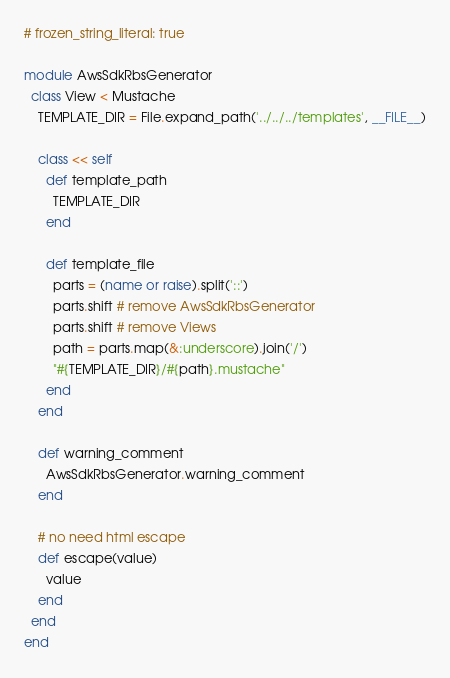<code> <loc_0><loc_0><loc_500><loc_500><_Ruby_># frozen_string_literal: true

module AwsSdkRbsGenerator
  class View < Mustache
    TEMPLATE_DIR = File.expand_path('../../../templates', __FILE__)

    class << self
      def template_path
        TEMPLATE_DIR
      end

      def template_file
        parts = (name or raise).split('::')
        parts.shift # remove AwsSdkRbsGenerator
        parts.shift # remove Views
        path = parts.map(&:underscore).join('/')
        "#{TEMPLATE_DIR}/#{path}.mustache"
      end
    end

    def warning_comment
      AwsSdkRbsGenerator.warning_comment
    end

    # no need html escape
    def escape(value)
      value
    end
  end
end
</code> 